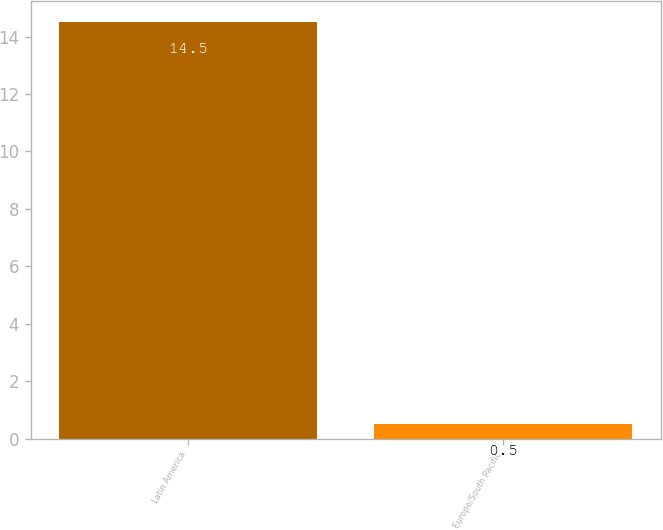Convert chart to OTSL. <chart><loc_0><loc_0><loc_500><loc_500><bar_chart><fcel>Latin America<fcel>Europe/South Pacific<nl><fcel>14.5<fcel>0.5<nl></chart> 